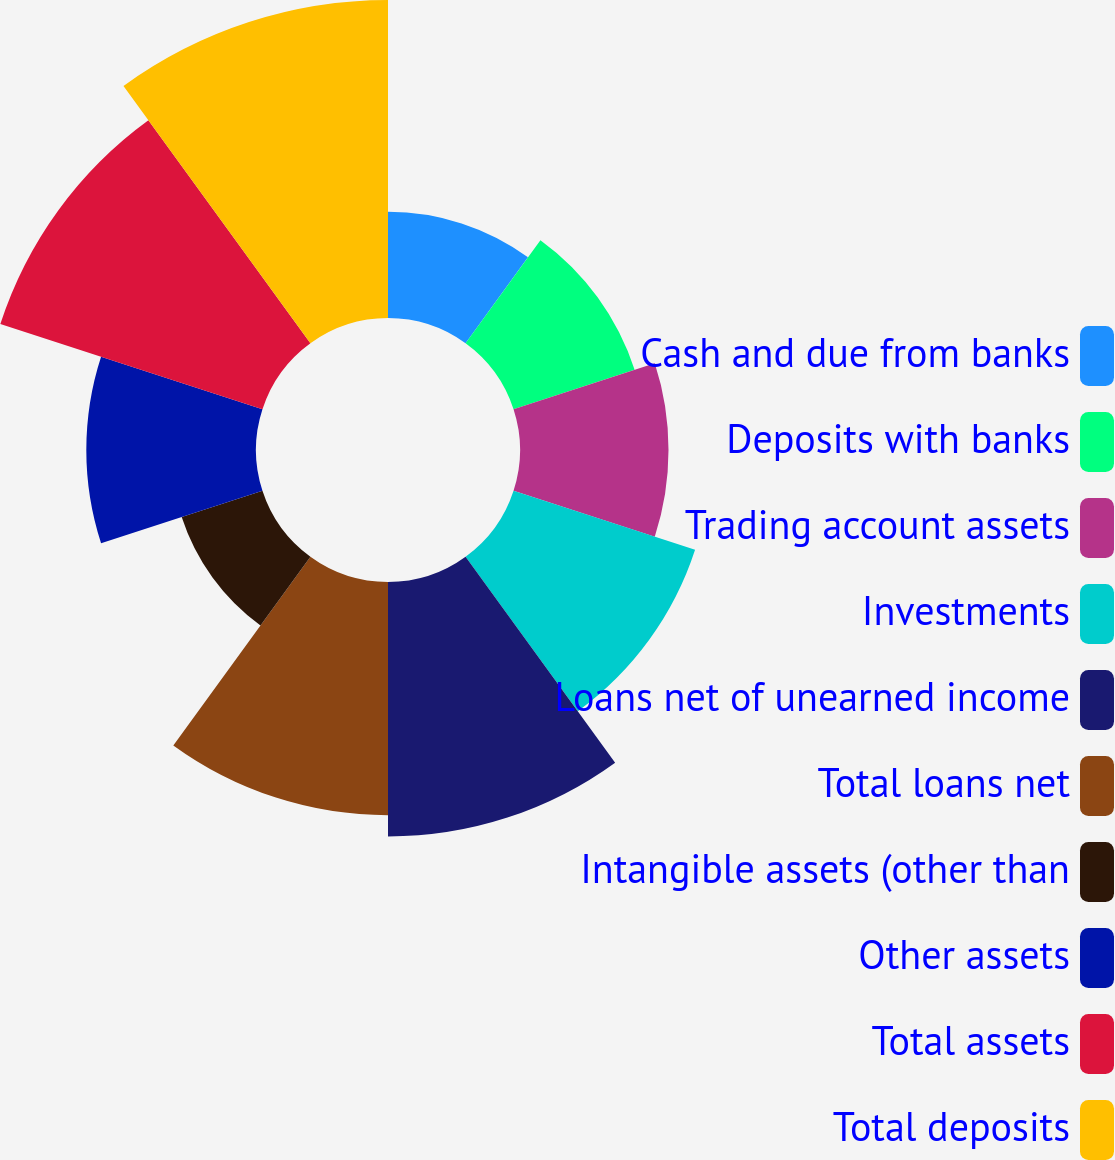<chart> <loc_0><loc_0><loc_500><loc_500><pie_chart><fcel>Cash and due from banks<fcel>Deposits with banks<fcel>Trading account assets<fcel>Investments<fcel>Loans net of unearned income<fcel>Total loans net<fcel>Intangible assets (other than<fcel>Other assets<fcel>Total assets<fcel>Total deposits<nl><fcel>5.56%<fcel>6.67%<fcel>7.78%<fcel>10.0%<fcel>13.33%<fcel>12.22%<fcel>4.45%<fcel>8.89%<fcel>14.44%<fcel>16.66%<nl></chart> 